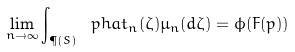<formula> <loc_0><loc_0><loc_500><loc_500>\lim _ { n \rightarrow \infty } \int _ { \P ( S ) } \ p h a t _ { n } ( \zeta ) \mu _ { n } ( d \zeta ) = \phi ( F ( p ) )</formula> 